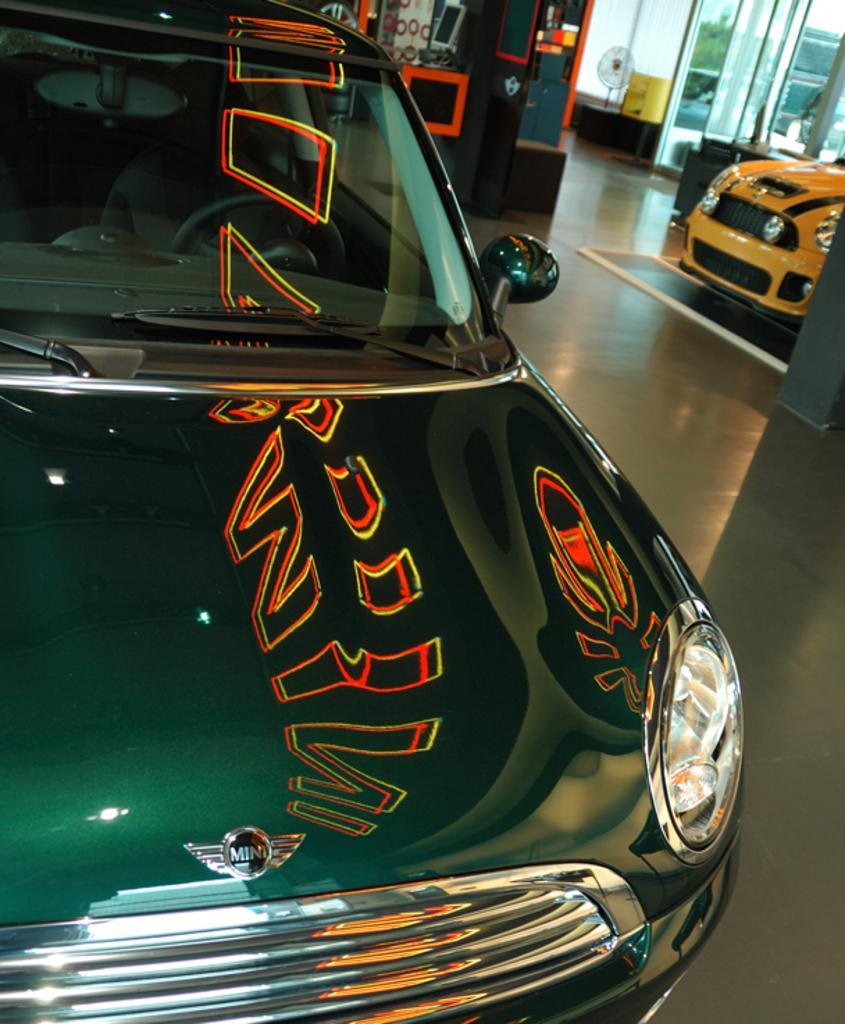Describe this image in one or two sentences. In this picture we can see few cars, in the background we can find few glasses and other things. 